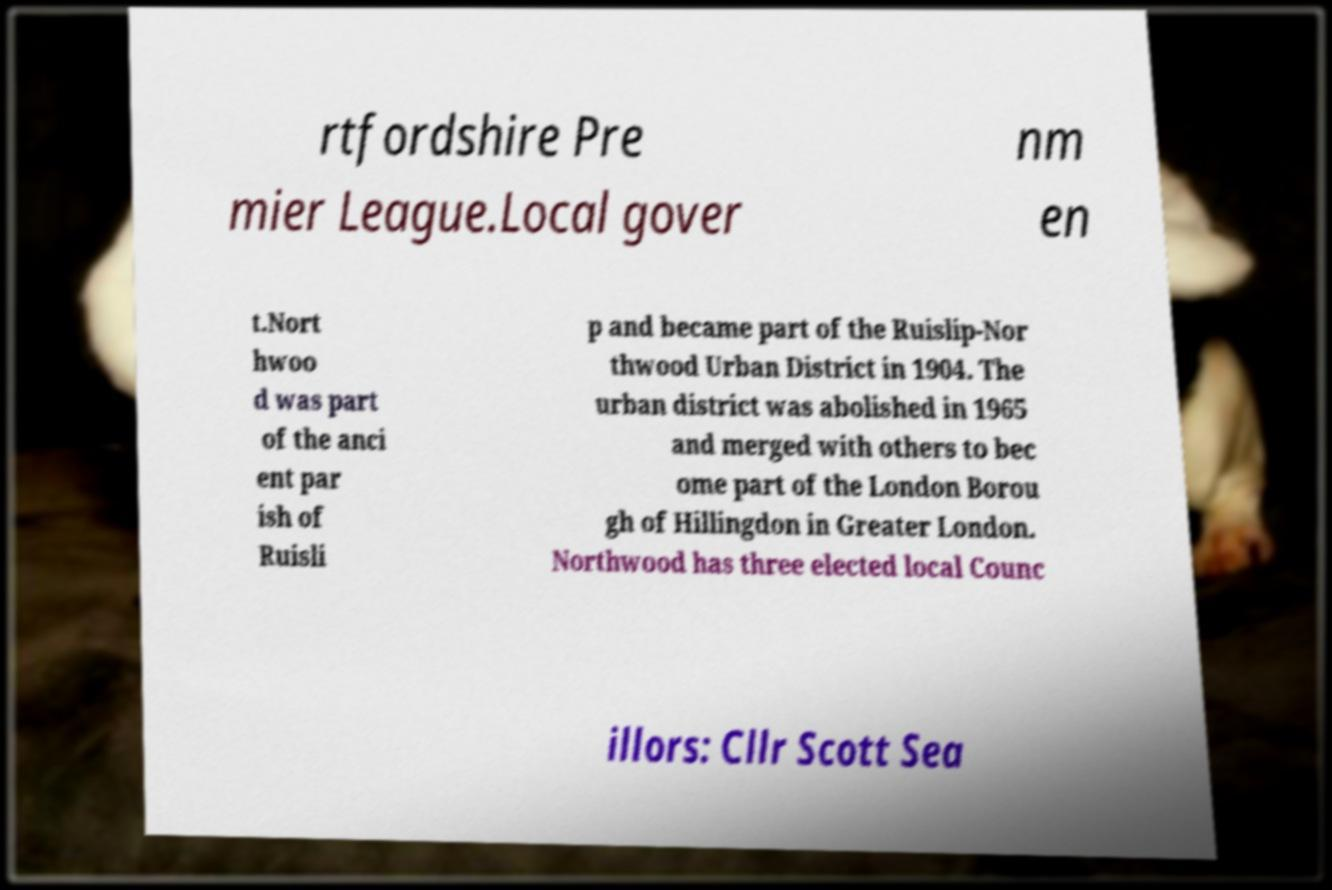Please identify and transcribe the text found in this image. rtfordshire Pre mier League.Local gover nm en t.Nort hwoo d was part of the anci ent par ish of Ruisli p and became part of the Ruislip-Nor thwood Urban District in 1904. The urban district was abolished in 1965 and merged with others to bec ome part of the London Borou gh of Hillingdon in Greater London. Northwood has three elected local Counc illors: Cllr Scott Sea 